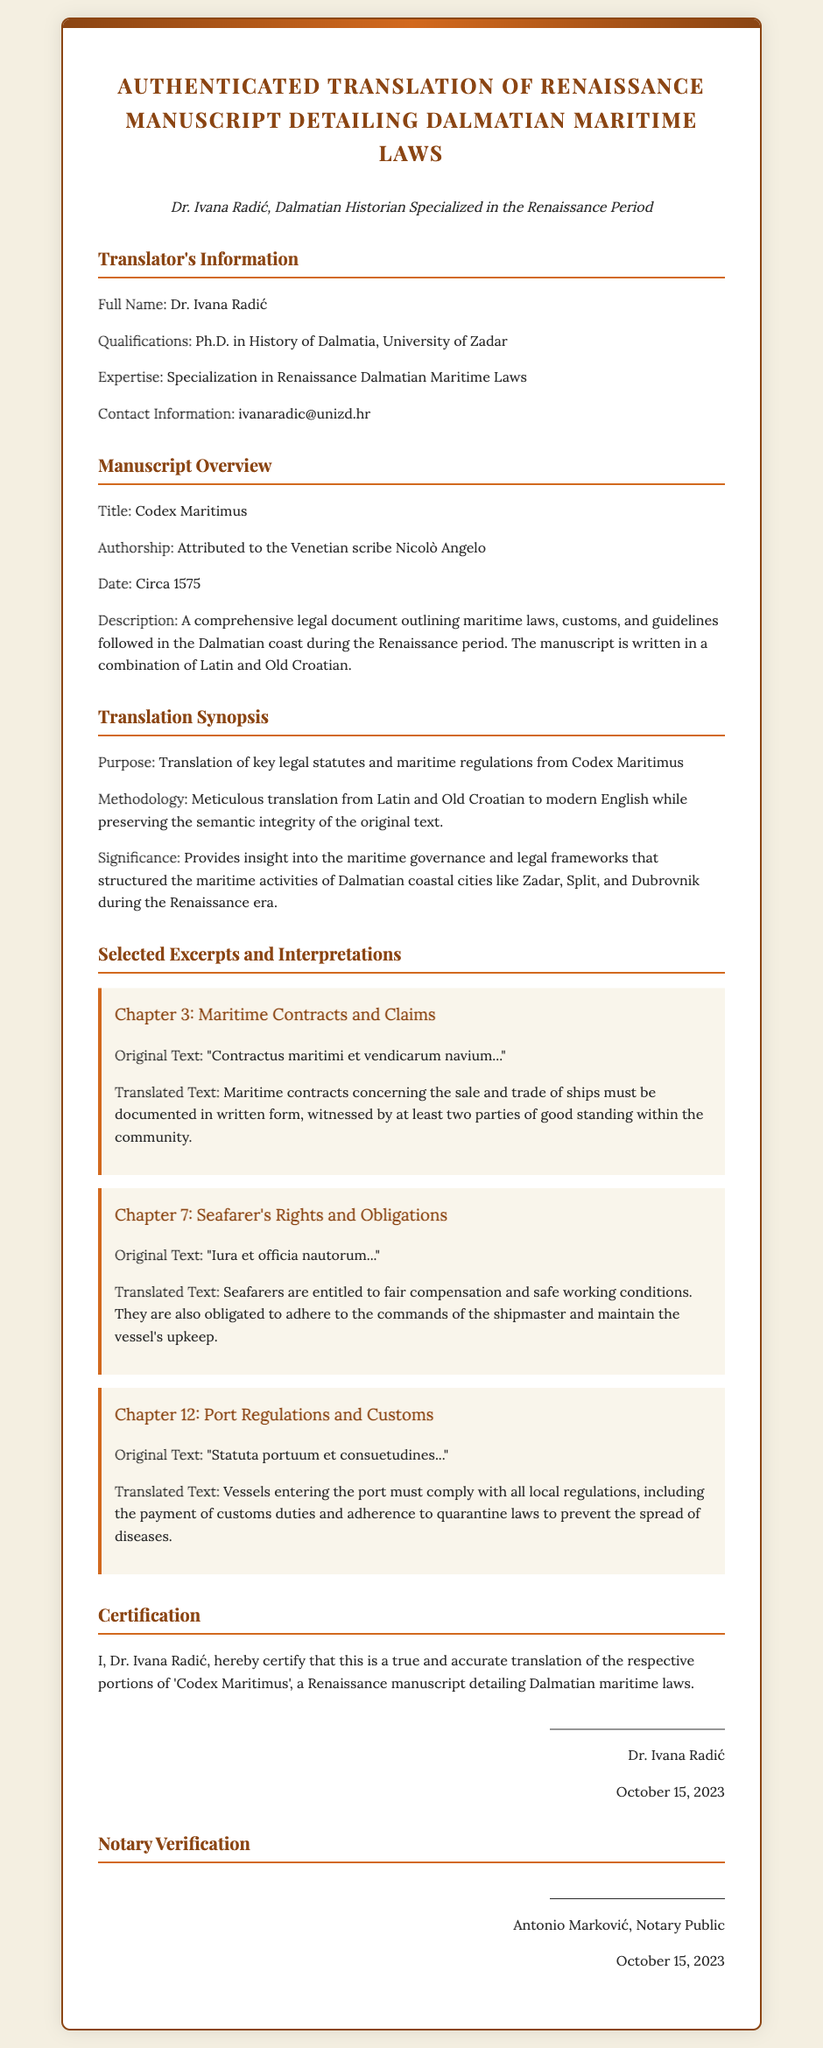what is the title of the manuscript? The title of the manuscript is provided in the overview section of the document, stating it as "Codex Maritimus."
Answer: Codex Maritimus who is the author of the manuscript? The authorship is attributed to the Venetian scribe Nicolò Angelo, mentioned in the manuscript overview.
Answer: Nicolò Angelo when was the manuscript created? The creation date of the manuscript is specified as "Circa 1575" in the overview section.
Answer: Circa 1575 who certified the translation? The certification is done by Dr. Ivana Radić, who is named in the certification section of the document.
Answer: Dr. Ivana Radić what is the primary focus of the manuscript? The primary focus is described as outlining maritime laws, customs, and guidelines in the Dalmatian coast during the Renaissance.
Answer: Maritime laws what methodology was used for the translation? The methodology is explained as "meticulous translation from Latin and Old Croatian to modern English," reflecting the process of maintaining semantic integrity.
Answer: Meticulous translation what does Chapter 3 discuss? Chapter 3 discusses maritime contracts and claims, specifically the requirements for documenting maritime contracts.
Answer: Maritime contracts and claims when was the document signed? The document includes the date of signing as "October 15, 2023," noted in both the certification and notary verification sections.
Answer: October 15, 2023 who performed the notary verification? The notary verification is conducted by Antonio Marković, indicated in the notary verification section of the document.
Answer: Antonio Marković 